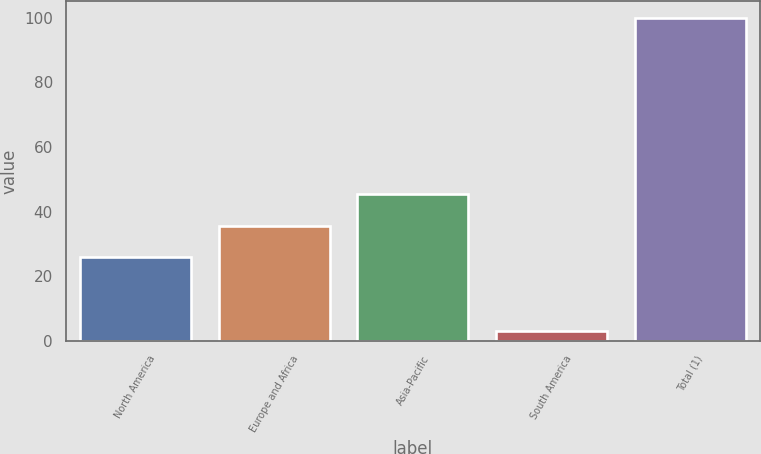<chart> <loc_0><loc_0><loc_500><loc_500><bar_chart><fcel>North America<fcel>Europe and Africa<fcel>Asia-Pacific<fcel>South America<fcel>Total (1)<nl><fcel>26<fcel>35.7<fcel>45.4<fcel>3<fcel>100<nl></chart> 